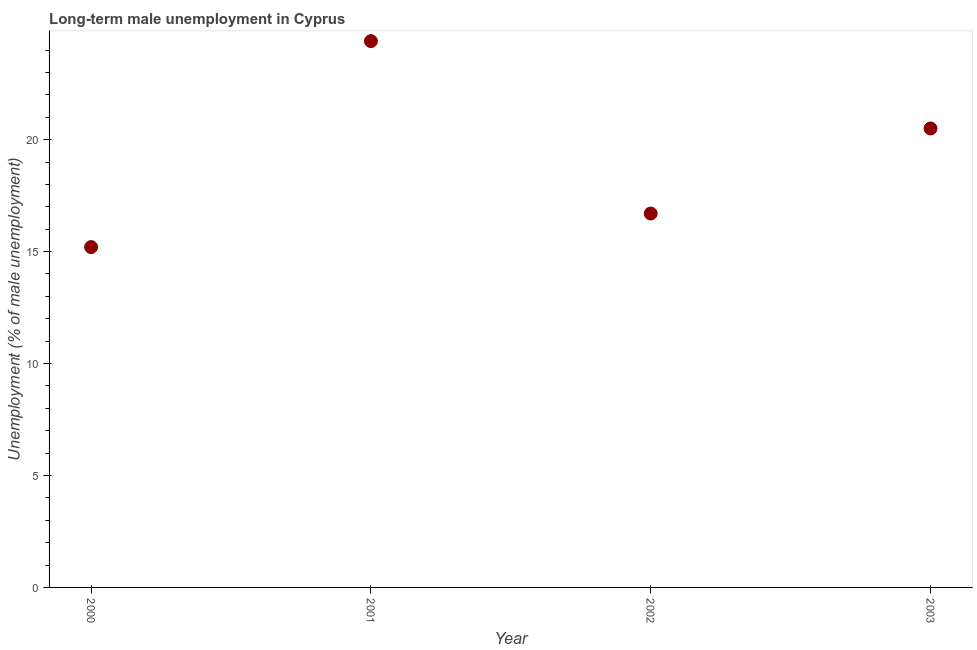What is the long-term male unemployment in 2002?
Your answer should be very brief. 16.7. Across all years, what is the maximum long-term male unemployment?
Provide a succinct answer. 24.4. Across all years, what is the minimum long-term male unemployment?
Offer a terse response. 15.2. What is the sum of the long-term male unemployment?
Offer a terse response. 76.8. What is the difference between the long-term male unemployment in 2000 and 2001?
Provide a succinct answer. -9.2. What is the average long-term male unemployment per year?
Ensure brevity in your answer.  19.2. What is the median long-term male unemployment?
Give a very brief answer. 18.6. Do a majority of the years between 2001 and 2002 (inclusive) have long-term male unemployment greater than 17 %?
Make the answer very short. No. What is the ratio of the long-term male unemployment in 2000 to that in 2002?
Provide a succinct answer. 0.91. Is the difference between the long-term male unemployment in 2000 and 2002 greater than the difference between any two years?
Ensure brevity in your answer.  No. What is the difference between the highest and the second highest long-term male unemployment?
Keep it short and to the point. 3.9. Is the sum of the long-term male unemployment in 2001 and 2002 greater than the maximum long-term male unemployment across all years?
Offer a very short reply. Yes. What is the difference between the highest and the lowest long-term male unemployment?
Give a very brief answer. 9.2. In how many years, is the long-term male unemployment greater than the average long-term male unemployment taken over all years?
Ensure brevity in your answer.  2. How many dotlines are there?
Your response must be concise. 1. What is the difference between two consecutive major ticks on the Y-axis?
Provide a succinct answer. 5. Are the values on the major ticks of Y-axis written in scientific E-notation?
Keep it short and to the point. No. Does the graph contain any zero values?
Provide a short and direct response. No. What is the title of the graph?
Your response must be concise. Long-term male unemployment in Cyprus. What is the label or title of the Y-axis?
Ensure brevity in your answer.  Unemployment (% of male unemployment). What is the Unemployment (% of male unemployment) in 2000?
Keep it short and to the point. 15.2. What is the Unemployment (% of male unemployment) in 2001?
Ensure brevity in your answer.  24.4. What is the Unemployment (% of male unemployment) in 2002?
Give a very brief answer. 16.7. What is the Unemployment (% of male unemployment) in 2003?
Give a very brief answer. 20.5. What is the difference between the Unemployment (% of male unemployment) in 2000 and 2002?
Offer a very short reply. -1.5. What is the difference between the Unemployment (% of male unemployment) in 2000 and 2003?
Offer a terse response. -5.3. What is the difference between the Unemployment (% of male unemployment) in 2001 and 2002?
Your response must be concise. 7.7. What is the difference between the Unemployment (% of male unemployment) in 2002 and 2003?
Make the answer very short. -3.8. What is the ratio of the Unemployment (% of male unemployment) in 2000 to that in 2001?
Offer a terse response. 0.62. What is the ratio of the Unemployment (% of male unemployment) in 2000 to that in 2002?
Keep it short and to the point. 0.91. What is the ratio of the Unemployment (% of male unemployment) in 2000 to that in 2003?
Provide a succinct answer. 0.74. What is the ratio of the Unemployment (% of male unemployment) in 2001 to that in 2002?
Offer a very short reply. 1.46. What is the ratio of the Unemployment (% of male unemployment) in 2001 to that in 2003?
Ensure brevity in your answer.  1.19. What is the ratio of the Unemployment (% of male unemployment) in 2002 to that in 2003?
Your answer should be very brief. 0.81. 